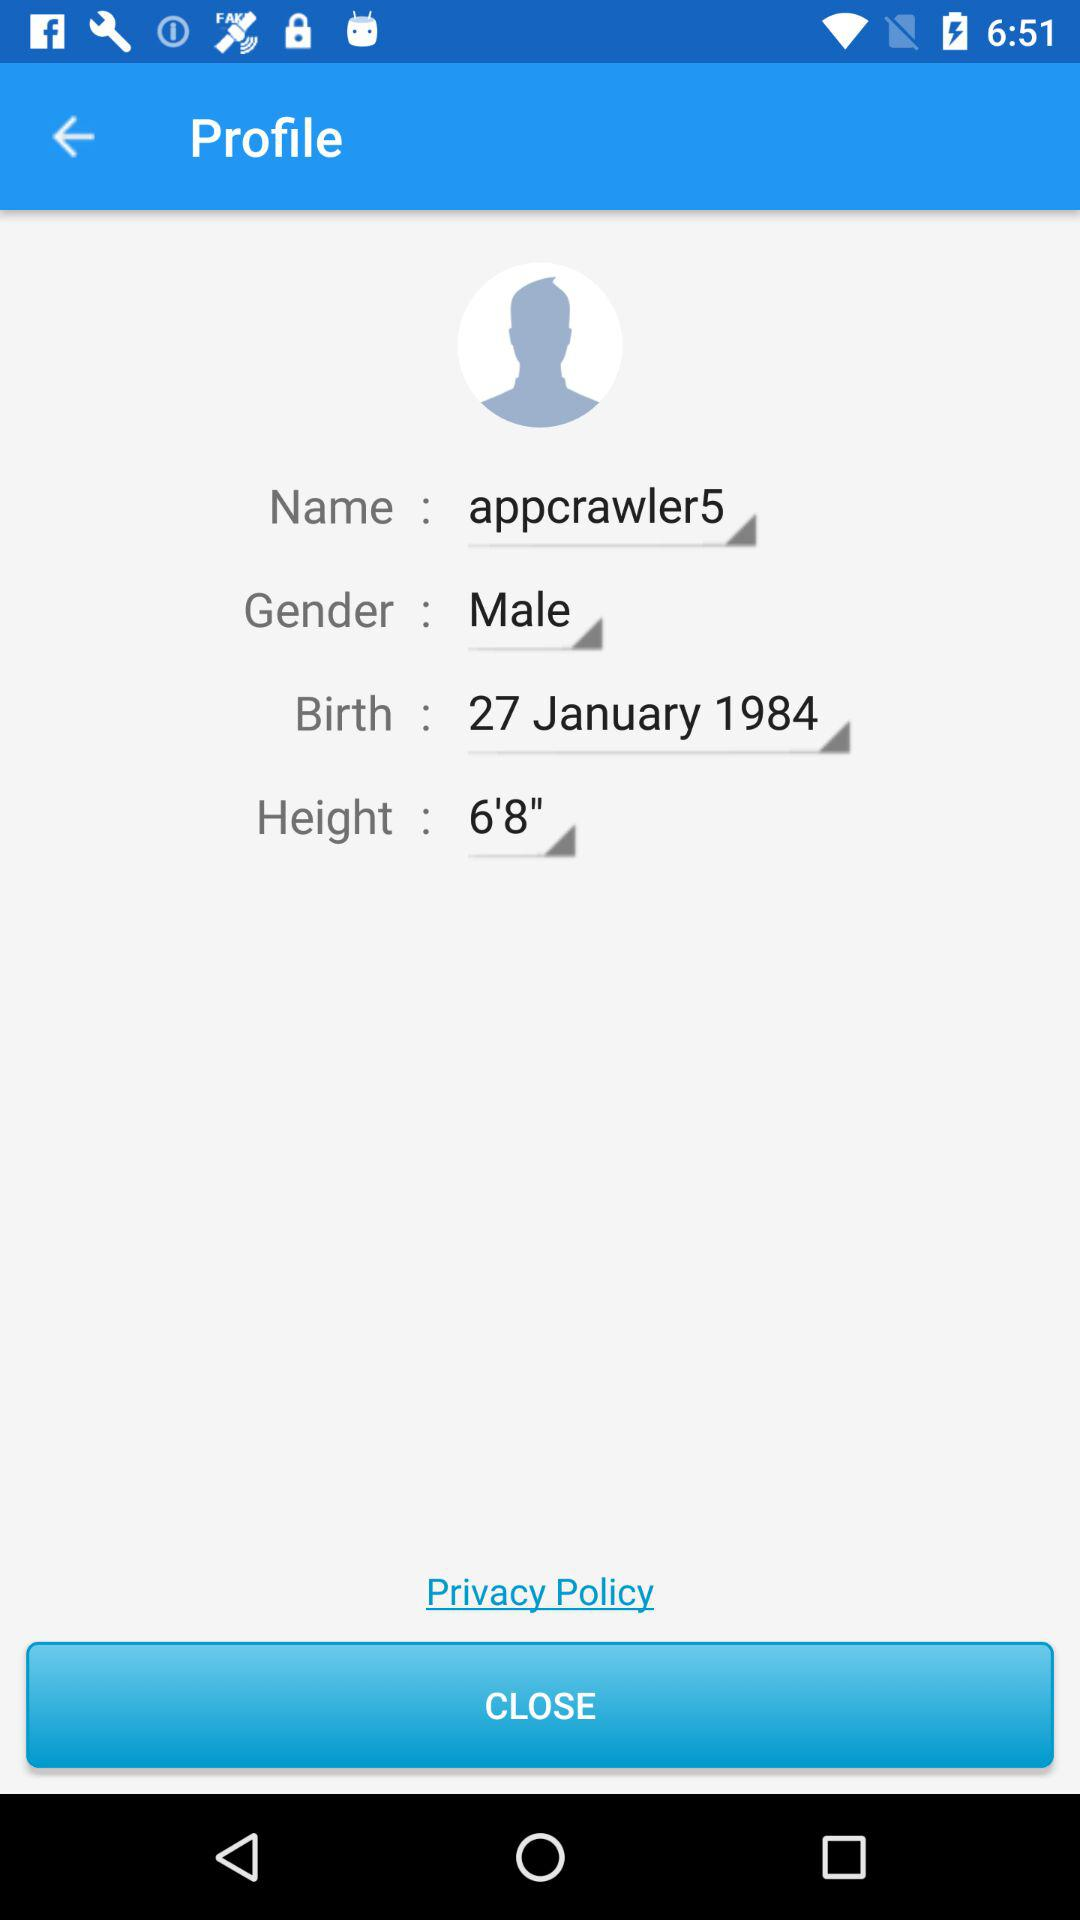What is the profile name? The profile name is "appcrawler5". 